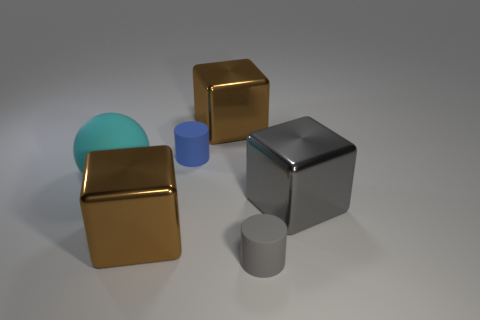The large cube that is in front of the large cyan rubber ball and on the left side of the large gray object is made of what material?
Make the answer very short. Metal. What shape is the gray object that is the same size as the cyan ball?
Provide a short and direct response. Cube. What is the color of the matte object that is in front of the large brown thing that is left of the cube that is behind the tiny blue cylinder?
Your answer should be very brief. Gray. What number of objects are either big gray metal blocks that are right of the small blue thing or large brown rubber spheres?
Offer a terse response. 1. There is a blue thing that is the same size as the gray rubber cylinder; what is it made of?
Make the answer very short. Rubber. What material is the small object behind the tiny matte cylinder on the right side of the shiny thing that is behind the blue rubber thing?
Offer a terse response. Rubber. The sphere has what color?
Your response must be concise. Cyan. What number of big objects are gray shiny cubes or metallic blocks?
Provide a short and direct response. 3. Does the large gray block that is to the right of the large ball have the same material as the big block that is behind the ball?
Your answer should be very brief. Yes. Is there a large rubber block?
Offer a terse response. No. 